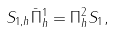<formula> <loc_0><loc_0><loc_500><loc_500>S _ { 1 , h } \bar { \Pi } _ { h } ^ { 1 } = \Pi _ { h } ^ { 2 } S _ { 1 } ,</formula> 